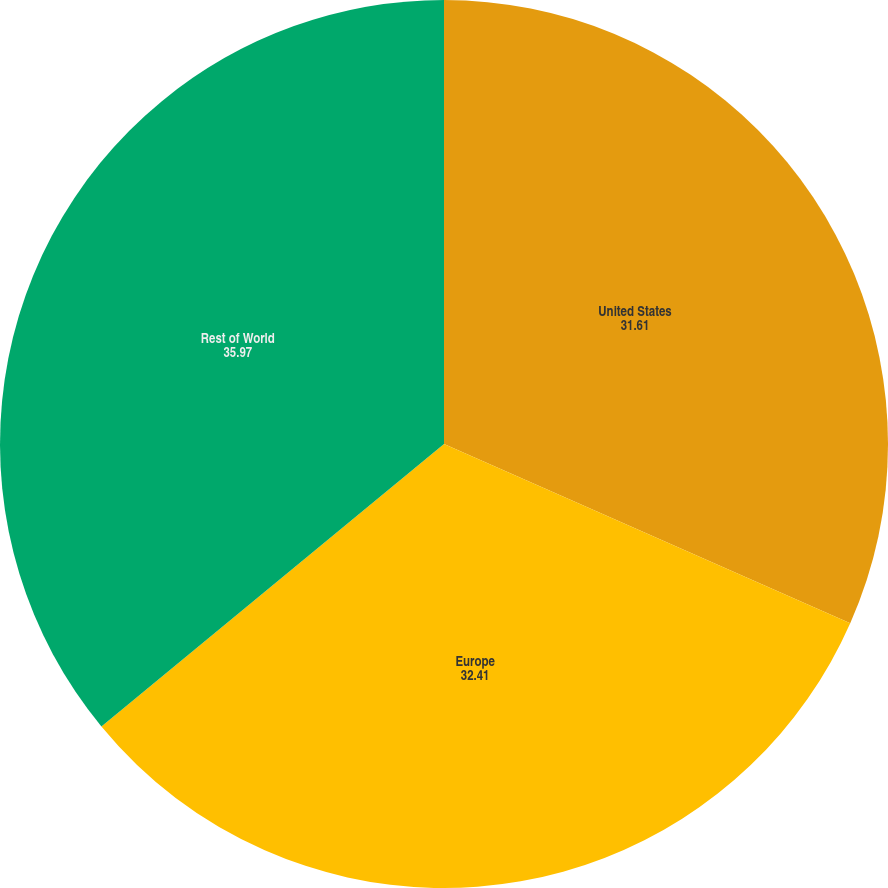Convert chart to OTSL. <chart><loc_0><loc_0><loc_500><loc_500><pie_chart><fcel>United States<fcel>Europe<fcel>Rest of World<nl><fcel>31.61%<fcel>32.41%<fcel>35.97%<nl></chart> 